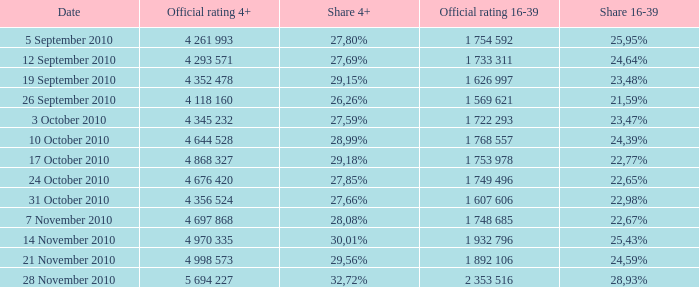What is the official 4+ rating of the episode with a 16-39 share of 24,59%? 4 998 573. 